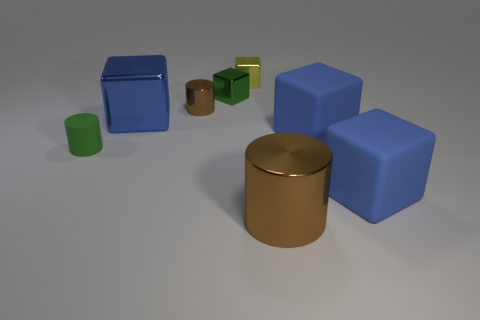Do the large shiny cylinder and the tiny shiny cylinder have the same color?
Provide a succinct answer. Yes. There is a tiny green thing that is the same shape as the small brown metallic object; what is it made of?
Your response must be concise. Rubber. There is a blue matte block that is behind the green rubber object; is its size the same as the large blue shiny cube?
Keep it short and to the point. Yes. How many rubber objects are green blocks or large cylinders?
Give a very brief answer. 0. What is the material of the cylinder that is both left of the tiny green metal cube and in front of the large metal cube?
Ensure brevity in your answer.  Rubber. Is the big brown object made of the same material as the yellow cube?
Ensure brevity in your answer.  Yes. There is a cylinder that is in front of the tiny brown object and on the left side of the large brown metallic cylinder; how big is it?
Make the answer very short. Small. There is a small yellow shiny thing; what shape is it?
Your answer should be very brief. Cube. What number of things are brown cylinders or cylinders that are to the left of the yellow cube?
Your response must be concise. 3. There is a large rubber object behind the green cylinder; is it the same color as the big metal cube?
Offer a terse response. Yes. 